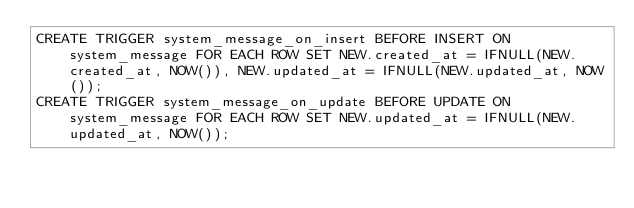Convert code to text. <code><loc_0><loc_0><loc_500><loc_500><_SQL_>CREATE TRIGGER system_message_on_insert BEFORE INSERT ON system_message FOR EACH ROW SET NEW.created_at = IFNULL(NEW.created_at, NOW()), NEW.updated_at = IFNULL(NEW.updated_at, NOW());
CREATE TRIGGER system_message_on_update BEFORE UPDATE ON system_message FOR EACH ROW SET NEW.updated_at = IFNULL(NEW.updated_at, NOW());
</code> 